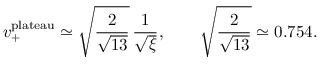<formula> <loc_0><loc_0><loc_500><loc_500>v _ { + } ^ { p l a t e a u } \simeq \sqrt { \frac { 2 } { \sqrt { 1 3 } } } \, \frac { 1 } { \sqrt { \xi } } , \quad \sqrt { \frac { 2 } { \sqrt { 1 3 } } } \simeq 0 . 7 5 4 .</formula> 